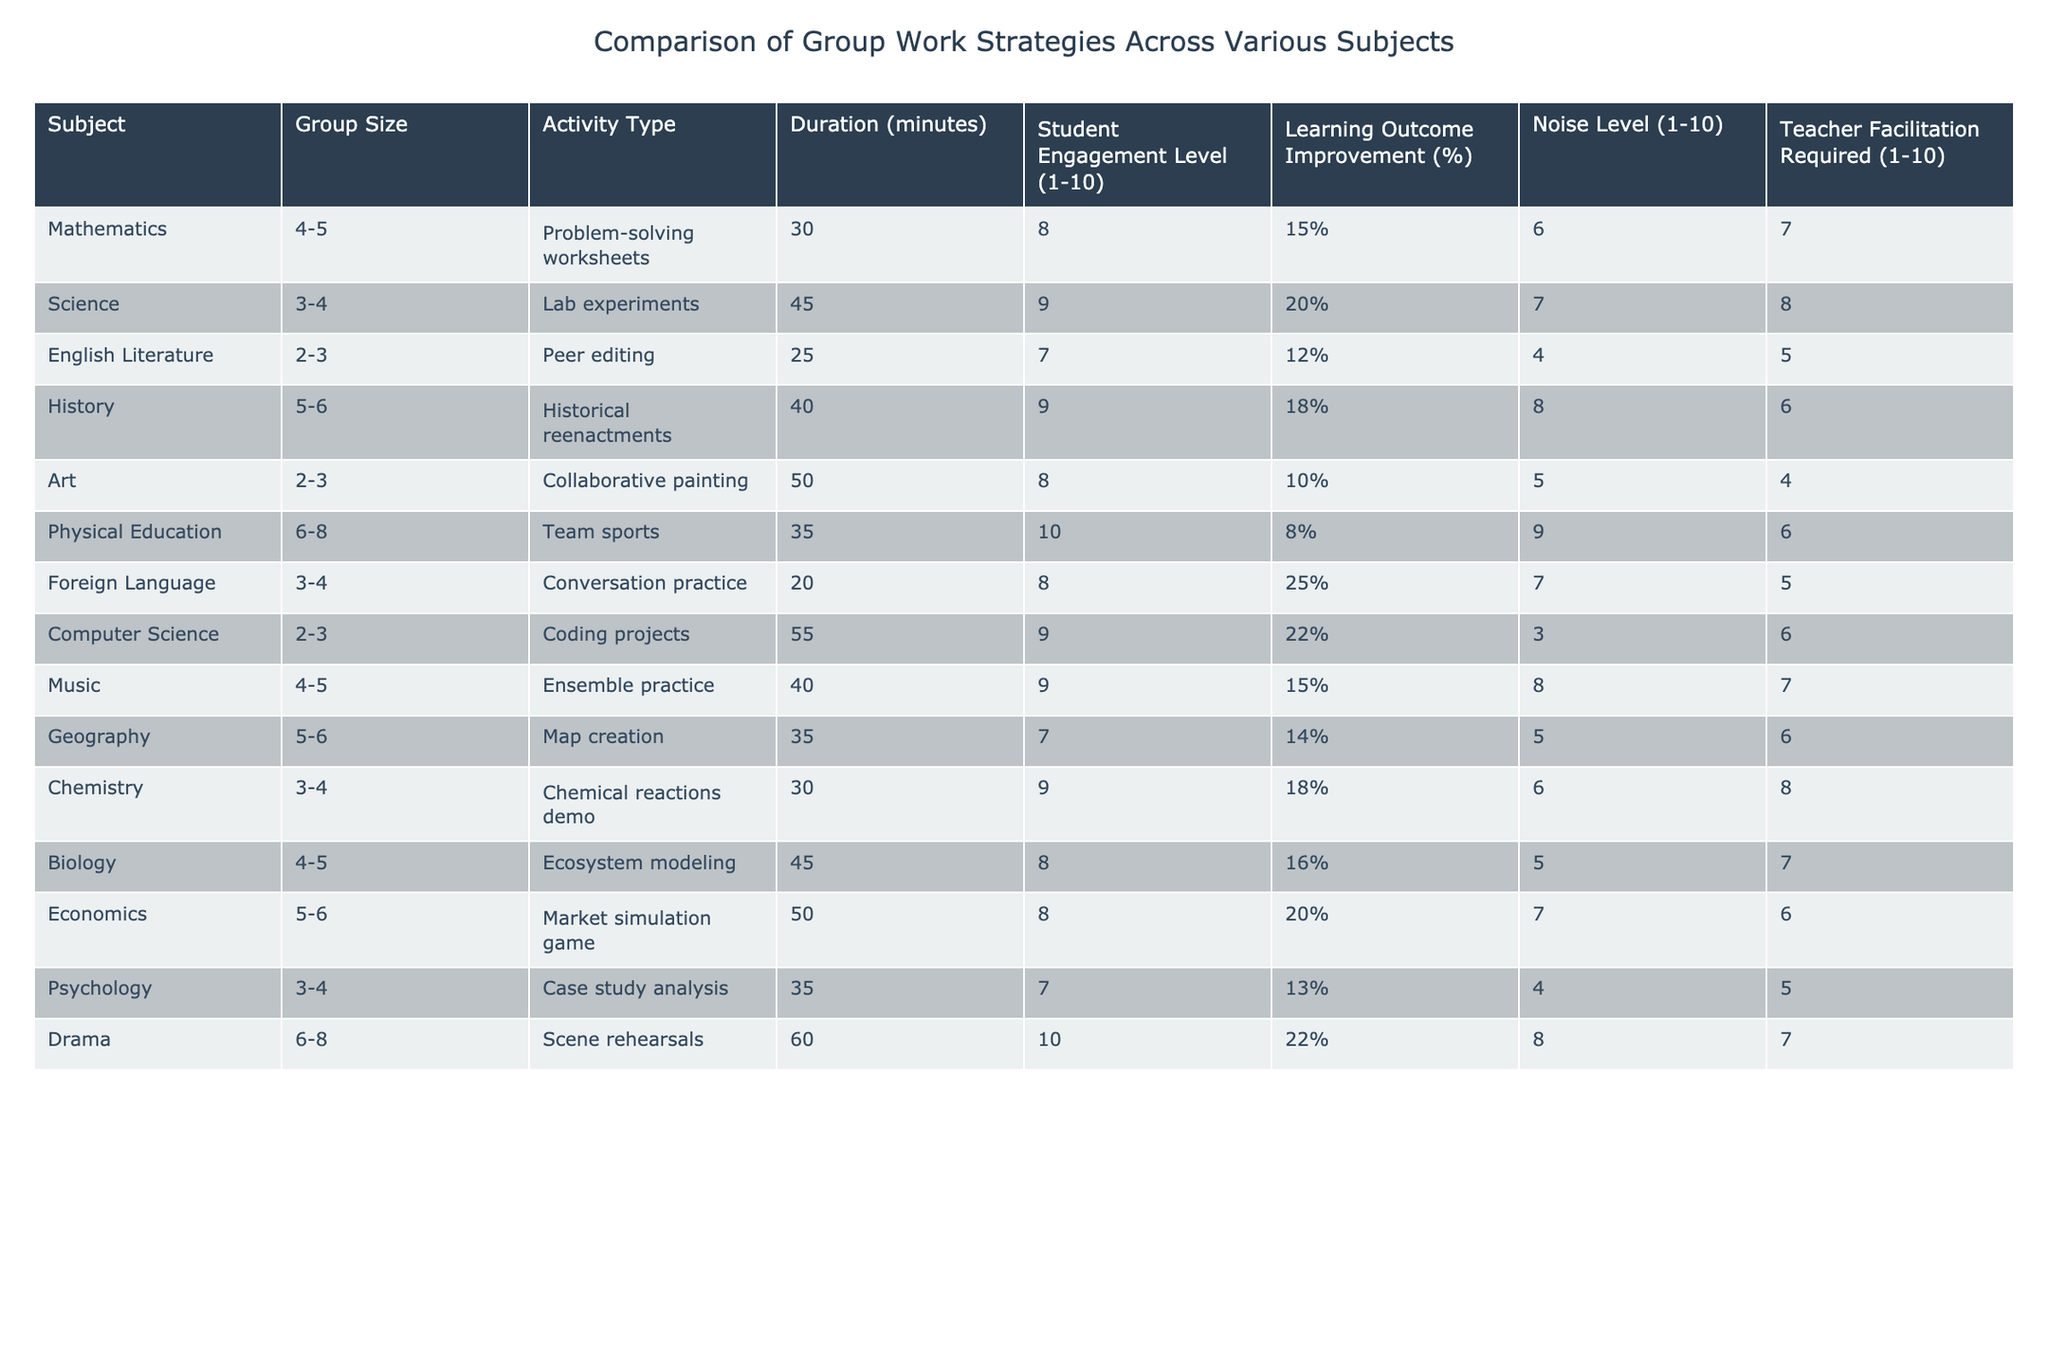What is the average student engagement level across all subjects? To find the average student engagement level, sum up all the engagement values: (8 + 9 + 7 + 9 + 8 + 10 + 8 + 9 + 4 + 7 + 9 + 8 + 7 + 10) = 109. There are 14 subjects, so divide the total by 14: 109/14 ≈ 7.79.
Answer: Approximately 7.79 Which subject has the highest noise level? Looking at the noise level column, Physical Education has the highest value of 9.
Answer: Physical Education Do any subjects have a learning outcome improvement greater than 20%? By checking the learning outcome improvement column, Foreign Language (25%), Computer Science (22%), and Drama (22%) all exceed 20%.
Answer: Yes What is the difference in duration between the shortest and longest group activity? The shortest duration is 20 minutes (Foreign Language), and the longest is 60 minutes (Drama). The difference is 60 - 20 = 40 minutes.
Answer: 40 minutes Which subject requires the least teacher facilitation? Comparing the teacher facilitation levels, Art has the lowest value of 4.
Answer: Art Is there a correlation between group size and student engagement level? To analyze this, we would look for trends in group size and engagement. The data shows varying sizes and engagement levels, but without specific numerical analysis, we cannot determine a clear correlation. Therefore, it seems there isn’t a consistent pattern.
Answer: No What percentage of subjects have a learning outcome improvement of less than 15%? By reviewing the learning outcome improvements: Mathematics (15%), English Literature (12%), Art (10%), and Psychology (13%) are less than 15%. This totals 4 subjects out of 14. Calculating the percentage gives (4/14) * 100 = approximately 28.57%.
Answer: Approximately 28.57% 